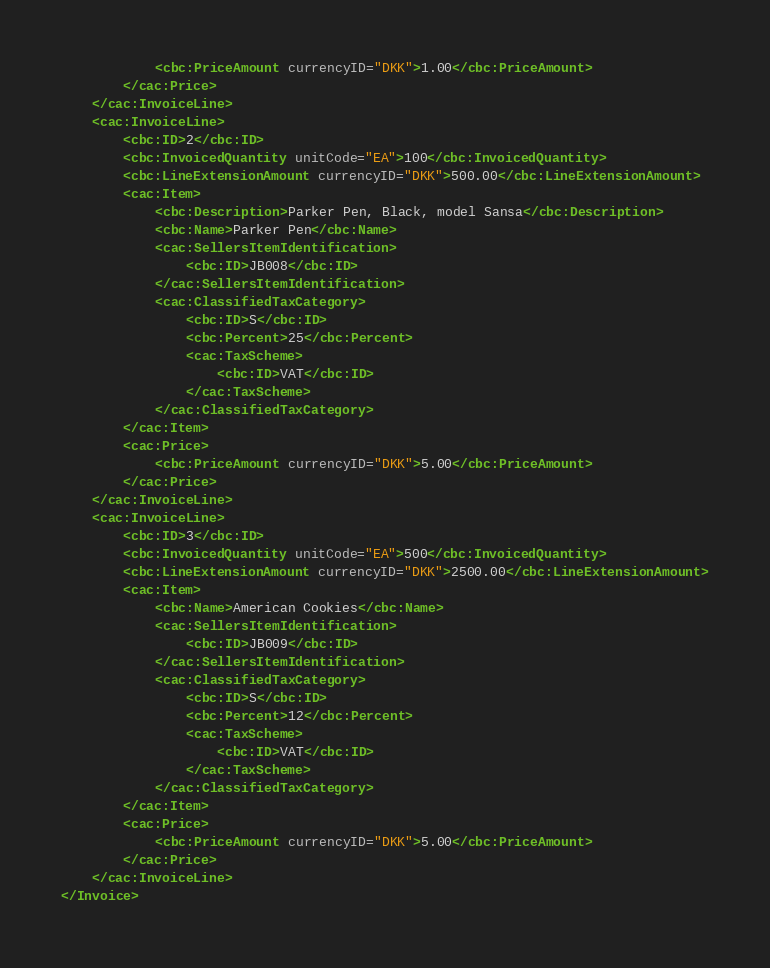<code> <loc_0><loc_0><loc_500><loc_500><_XML_>            <cbc:PriceAmount currencyID="DKK">1.00</cbc:PriceAmount>
        </cac:Price>
    </cac:InvoiceLine>
    <cac:InvoiceLine>
        <cbc:ID>2</cbc:ID>
        <cbc:InvoicedQuantity unitCode="EA">100</cbc:InvoicedQuantity>
        <cbc:LineExtensionAmount currencyID="DKK">500.00</cbc:LineExtensionAmount>
        <cac:Item>
            <cbc:Description>Parker Pen, Black, model Sansa</cbc:Description>
            <cbc:Name>Parker Pen</cbc:Name>
            <cac:SellersItemIdentification>
                <cbc:ID>JB008</cbc:ID>
            </cac:SellersItemIdentification>
            <cac:ClassifiedTaxCategory>
                <cbc:ID>S</cbc:ID>
                <cbc:Percent>25</cbc:Percent>
                <cac:TaxScheme>
                    <cbc:ID>VAT</cbc:ID>
                </cac:TaxScheme>
            </cac:ClassifiedTaxCategory>
        </cac:Item>
        <cac:Price>
            <cbc:PriceAmount currencyID="DKK">5.00</cbc:PriceAmount>
        </cac:Price>
    </cac:InvoiceLine>
    <cac:InvoiceLine>
        <cbc:ID>3</cbc:ID>
        <cbc:InvoicedQuantity unitCode="EA">500</cbc:InvoicedQuantity>
        <cbc:LineExtensionAmount currencyID="DKK">2500.00</cbc:LineExtensionAmount>
        <cac:Item>
            <cbc:Name>American Cookies</cbc:Name>
            <cac:SellersItemIdentification>
                <cbc:ID>JB009</cbc:ID>
            </cac:SellersItemIdentification>
            <cac:ClassifiedTaxCategory>
                <cbc:ID>S</cbc:ID>
                <cbc:Percent>12</cbc:Percent>
                <cac:TaxScheme>
                    <cbc:ID>VAT</cbc:ID>
                </cac:TaxScheme>
            </cac:ClassifiedTaxCategory>
        </cac:Item>
        <cac:Price>
            <cbc:PriceAmount currencyID="DKK">5.00</cbc:PriceAmount>
        </cac:Price>
    </cac:InvoiceLine>
</Invoice>
</code> 